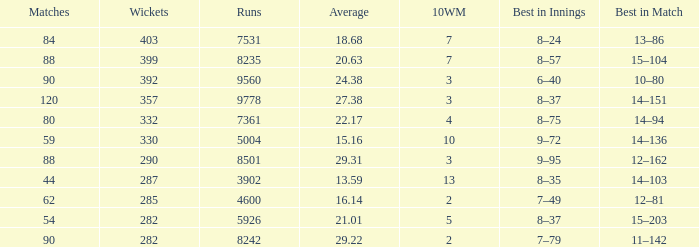How many wickets have runs under 7531, matches over 44, and an average of 22.17? 332.0. 